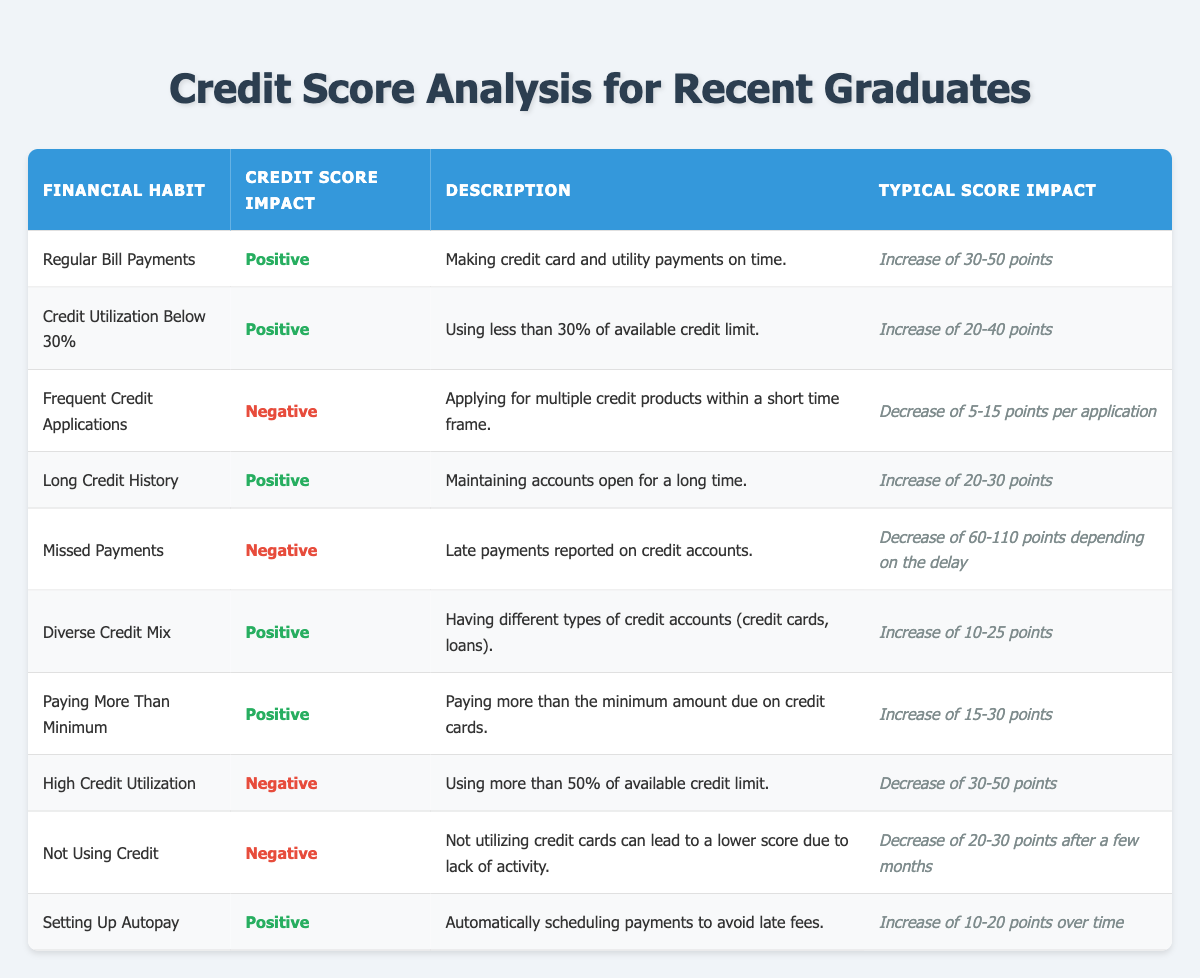What is the typical score impact of "Regular Bill Payments"? Looking at the row for "Regular Bill Payments," the typical score impact is listed as an increase of 30-50 points.
Answer: Increase of 30-50 points Which financial habit has the most negative impact on your credit score? The habit with the most negative impact is "Missed Payments," which can decrease the score by 60-110 points depending on the delay.
Answer: Missed Payments Is paying more than the minimum due on credit cards beneficial to your credit score? Yes, according to the table, paying more than the minimum amount due has a positive credit score impact and can increase the score by 15-30 points.
Answer: Yes What is the combined typical score impact of "High Credit Utilization" and "Frequent Credit Applications"? "High Credit Utilization" decreases the score by 30-50 points, and "Frequent Credit Applications" decreases the score by 5-15 points per application. For simplicity, we can take midpoints: 40 + 10 = 50, which is the combined impact.
Answer: Decrease of 50 points If a graduate sets up autopay, how much might their score increase? Referring to the "Setting Up Autopay" row, it mentions that the typical score impact is an increase of 10-20 points over time.
Answer: Increase of 10-20 points Did "Not Using Credit" lead to a positive impact on credit scores? No, the table indicates that "Not Using Credit" results in a negative impact, decreasing the score by 20-30 points after a few months.
Answer: No What is the average score increase from maintaining a long credit history and making regular bill payments? According to the table, "Long Credit History" typically increases the score by 20-30 points, and "Regular Bill Payments" increases it by 30-50 points. The averages are (25 + 40)/2 = 32.5.
Answer: Average increase of 32.5 points Is having a diverse credit mix beneficial? Yes, the table shows that having a diverse credit mix results in a positive credit score impact, increasing the score by 10-25 points.
Answer: Yes 